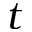<formula> <loc_0><loc_0><loc_500><loc_500>t</formula> 